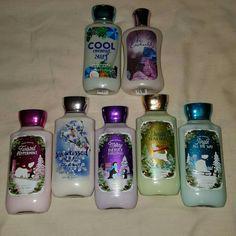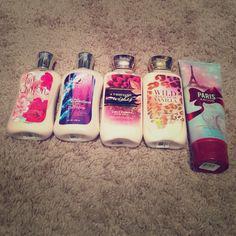The first image is the image on the left, the second image is the image on the right. Evaluate the accuracy of this statement regarding the images: "An image shows a product with orange-and-white tube-type container standing upright on its cap.". Is it true? Answer yes or no. No. 